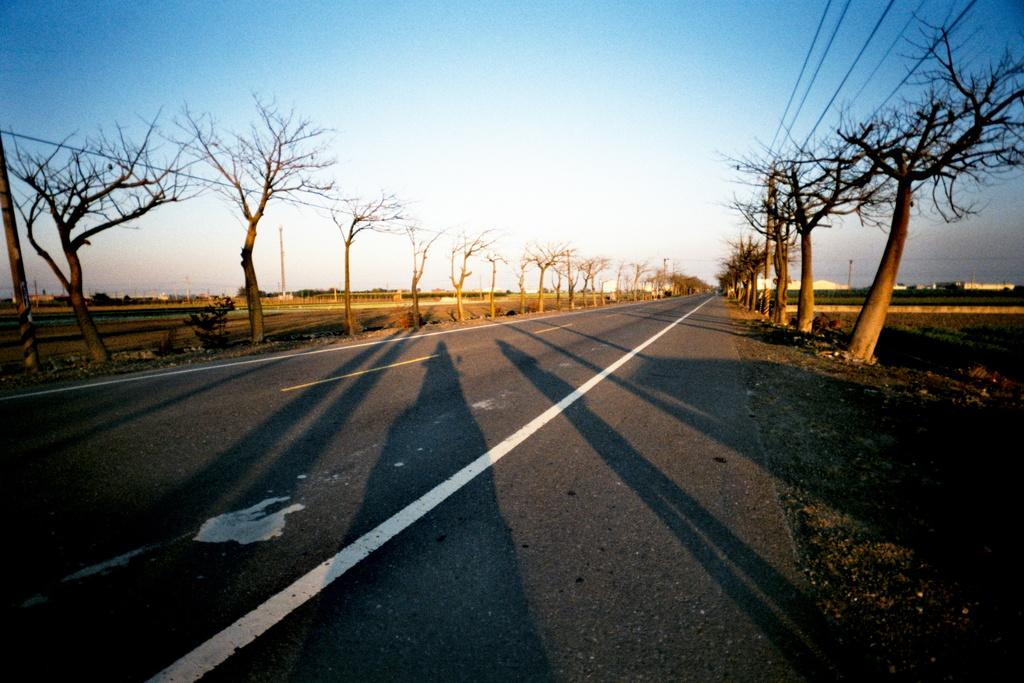What is the main feature of the image? There is a road in the image. What can be seen on the road? White lines are visible on the road. What else is present in the image besides the road? There are electric wires, a plant, trees, and the sky visible in the image. How many cattle can be seen grazing on the side of the road in the image? There are no cattle present in the image. What type of lizards can be seen crawling on the electric wires in the image? There are no lizards present in the image; the electric wires are not associated with any animals. 